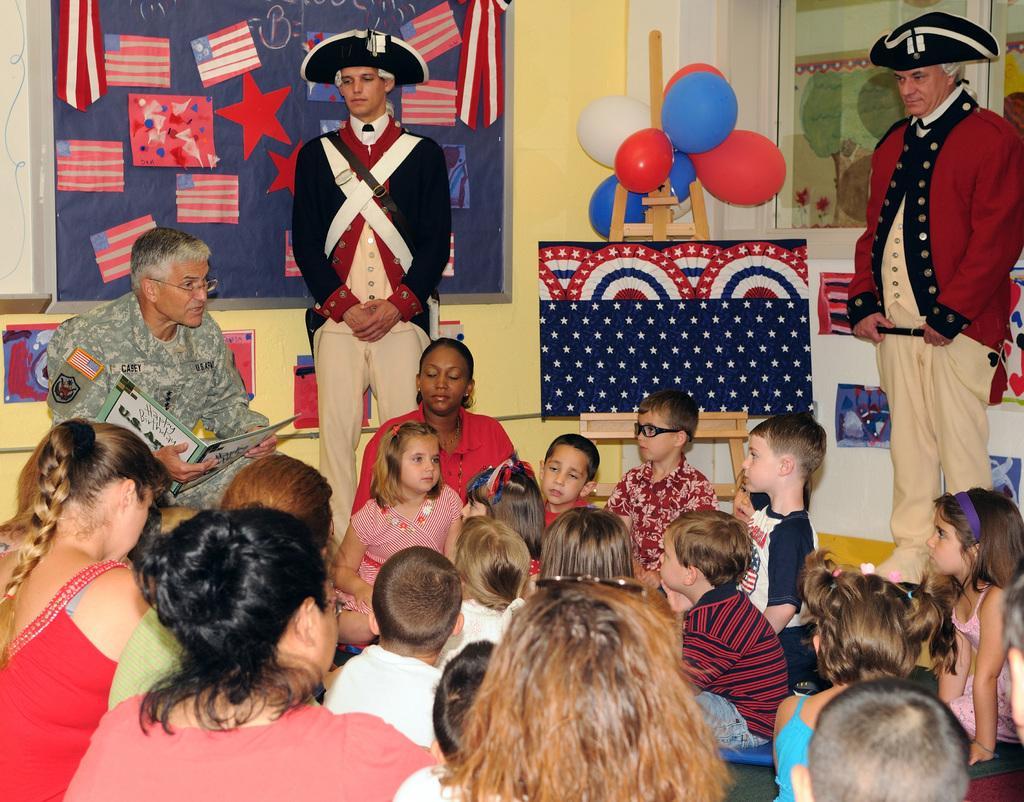Describe this image in one or two sentences. In this picture in the front of there are persons sitting. In the background there are persons standing, there are frames on the wall, on the frame there are flags, there are balloons and in the center there is a person sitting and holding a book in his hand with some text written on it. 